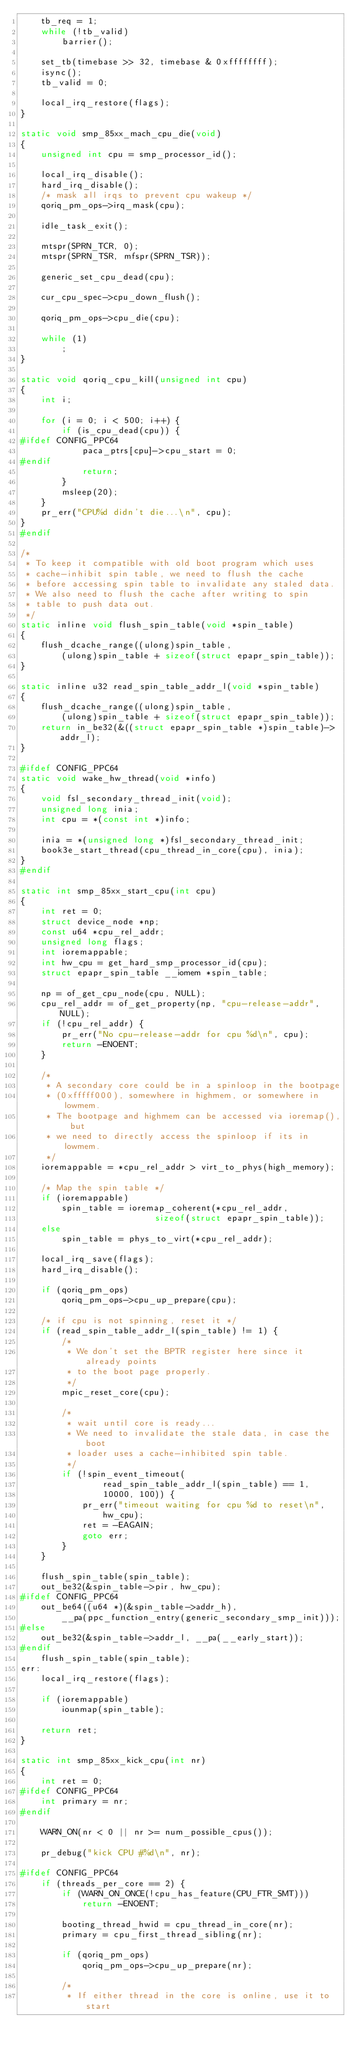<code> <loc_0><loc_0><loc_500><loc_500><_C_>	tb_req = 1;
	while (!tb_valid)
		barrier();

	set_tb(timebase >> 32, timebase & 0xffffffff);
	isync();
	tb_valid = 0;

	local_irq_restore(flags);
}

static void smp_85xx_mach_cpu_die(void)
{
	unsigned int cpu = smp_processor_id();

	local_irq_disable();
	hard_irq_disable();
	/* mask all irqs to prevent cpu wakeup */
	qoriq_pm_ops->irq_mask(cpu);

	idle_task_exit();

	mtspr(SPRN_TCR, 0);
	mtspr(SPRN_TSR, mfspr(SPRN_TSR));

	generic_set_cpu_dead(cpu);

	cur_cpu_spec->cpu_down_flush();

	qoriq_pm_ops->cpu_die(cpu);

	while (1)
		;
}

static void qoriq_cpu_kill(unsigned int cpu)
{
	int i;

	for (i = 0; i < 500; i++) {
		if (is_cpu_dead(cpu)) {
#ifdef CONFIG_PPC64
			paca_ptrs[cpu]->cpu_start = 0;
#endif
			return;
		}
		msleep(20);
	}
	pr_err("CPU%d didn't die...\n", cpu);
}
#endif

/*
 * To keep it compatible with old boot program which uses
 * cache-inhibit spin table, we need to flush the cache
 * before accessing spin table to invalidate any staled data.
 * We also need to flush the cache after writing to spin
 * table to push data out.
 */
static inline void flush_spin_table(void *spin_table)
{
	flush_dcache_range((ulong)spin_table,
		(ulong)spin_table + sizeof(struct epapr_spin_table));
}

static inline u32 read_spin_table_addr_l(void *spin_table)
{
	flush_dcache_range((ulong)spin_table,
		(ulong)spin_table + sizeof(struct epapr_spin_table));
	return in_be32(&((struct epapr_spin_table *)spin_table)->addr_l);
}

#ifdef CONFIG_PPC64
static void wake_hw_thread(void *info)
{
	void fsl_secondary_thread_init(void);
	unsigned long inia;
	int cpu = *(const int *)info;

	inia = *(unsigned long *)fsl_secondary_thread_init;
	book3e_start_thread(cpu_thread_in_core(cpu), inia);
}
#endif

static int smp_85xx_start_cpu(int cpu)
{
	int ret = 0;
	struct device_node *np;
	const u64 *cpu_rel_addr;
	unsigned long flags;
	int ioremappable;
	int hw_cpu = get_hard_smp_processor_id(cpu);
	struct epapr_spin_table __iomem *spin_table;

	np = of_get_cpu_node(cpu, NULL);
	cpu_rel_addr = of_get_property(np, "cpu-release-addr", NULL);
	if (!cpu_rel_addr) {
		pr_err("No cpu-release-addr for cpu %d\n", cpu);
		return -ENOENT;
	}

	/*
	 * A secondary core could be in a spinloop in the bootpage
	 * (0xfffff000), somewhere in highmem, or somewhere in lowmem.
	 * The bootpage and highmem can be accessed via ioremap(), but
	 * we need to directly access the spinloop if its in lowmem.
	 */
	ioremappable = *cpu_rel_addr > virt_to_phys(high_memory);

	/* Map the spin table */
	if (ioremappable)
		spin_table = ioremap_coherent(*cpu_rel_addr,
					      sizeof(struct epapr_spin_table));
	else
		spin_table = phys_to_virt(*cpu_rel_addr);

	local_irq_save(flags);
	hard_irq_disable();

	if (qoriq_pm_ops)
		qoriq_pm_ops->cpu_up_prepare(cpu);

	/* if cpu is not spinning, reset it */
	if (read_spin_table_addr_l(spin_table) != 1) {
		/*
		 * We don't set the BPTR register here since it already points
		 * to the boot page properly.
		 */
		mpic_reset_core(cpu);

		/*
		 * wait until core is ready...
		 * We need to invalidate the stale data, in case the boot
		 * loader uses a cache-inhibited spin table.
		 */
		if (!spin_event_timeout(
				read_spin_table_addr_l(spin_table) == 1,
				10000, 100)) {
			pr_err("timeout waiting for cpu %d to reset\n",
				hw_cpu);
			ret = -EAGAIN;
			goto err;
		}
	}

	flush_spin_table(spin_table);
	out_be32(&spin_table->pir, hw_cpu);
#ifdef CONFIG_PPC64
	out_be64((u64 *)(&spin_table->addr_h),
		__pa(ppc_function_entry(generic_secondary_smp_init)));
#else
	out_be32(&spin_table->addr_l, __pa(__early_start));
#endif
	flush_spin_table(spin_table);
err:
	local_irq_restore(flags);

	if (ioremappable)
		iounmap(spin_table);

	return ret;
}

static int smp_85xx_kick_cpu(int nr)
{
	int ret = 0;
#ifdef CONFIG_PPC64
	int primary = nr;
#endif

	WARN_ON(nr < 0 || nr >= num_possible_cpus());

	pr_debug("kick CPU #%d\n", nr);

#ifdef CONFIG_PPC64
	if (threads_per_core == 2) {
		if (WARN_ON_ONCE(!cpu_has_feature(CPU_FTR_SMT)))
			return -ENOENT;

		booting_thread_hwid = cpu_thread_in_core(nr);
		primary = cpu_first_thread_sibling(nr);

		if (qoriq_pm_ops)
			qoriq_pm_ops->cpu_up_prepare(nr);

		/*
		 * If either thread in the core is online, use it to start</code> 